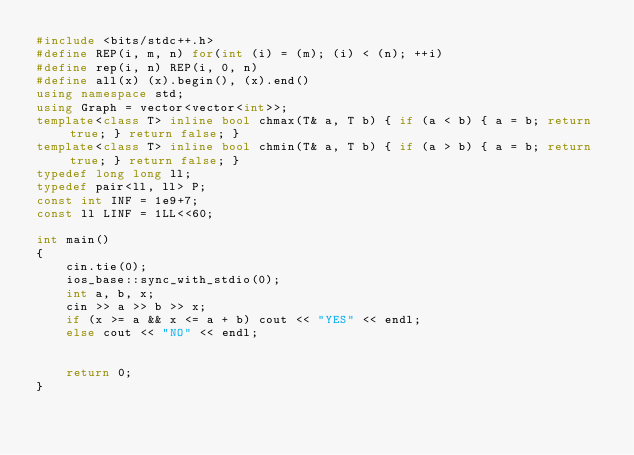<code> <loc_0><loc_0><loc_500><loc_500><_C++_>#include <bits/stdc++.h>
#define REP(i, m, n) for(int (i) = (m); (i) < (n); ++i)
#define rep(i, n) REP(i, 0, n)
#define all(x) (x).begin(), (x).end()
using namespace std;
using Graph = vector<vector<int>>;
template<class T> inline bool chmax(T& a, T b) { if (a < b) { a = b; return true; } return false; }
template<class T> inline bool chmin(T& a, T b) { if (a > b) { a = b; return true; } return false; }
typedef long long ll;
typedef pair<ll, ll> P;
const int INF = 1e9+7;
const ll LINF = 1LL<<60;

int main()
{
    cin.tie(0);
    ios_base::sync_with_stdio(0);
    int a, b, x;
    cin >> a >> b >> x;
    if (x >= a && x <= a + b) cout << "YES" << endl;
    else cout << "NO" << endl;


    return 0;
}</code> 